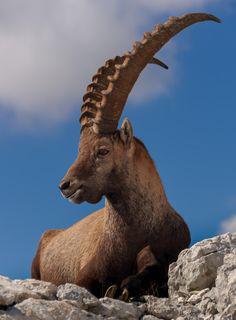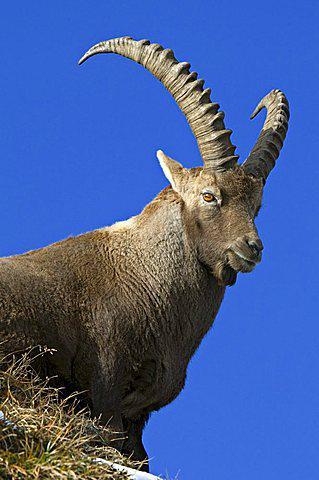The first image is the image on the left, the second image is the image on the right. Analyze the images presented: Is the assertion "The images show a single horned animal, and they face in different [left or right] directions." valid? Answer yes or no. Yes. The first image is the image on the left, the second image is the image on the right. Given the left and right images, does the statement "Exactly one animal is facing to the left." hold true? Answer yes or no. Yes. 